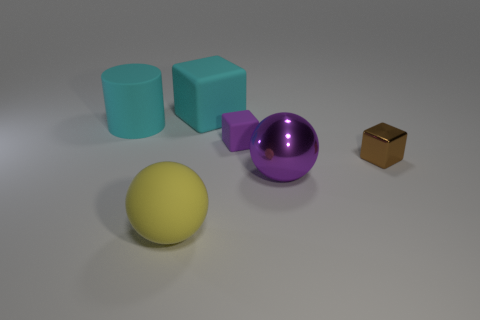Add 2 rubber blocks. How many objects exist? 8 Subtract all balls. How many objects are left? 4 Subtract 0 yellow cylinders. How many objects are left? 6 Subtract all tiny purple things. Subtract all large rubber things. How many objects are left? 2 Add 1 small brown things. How many small brown things are left? 2 Add 2 tiny blue matte balls. How many tiny blue matte balls exist? 2 